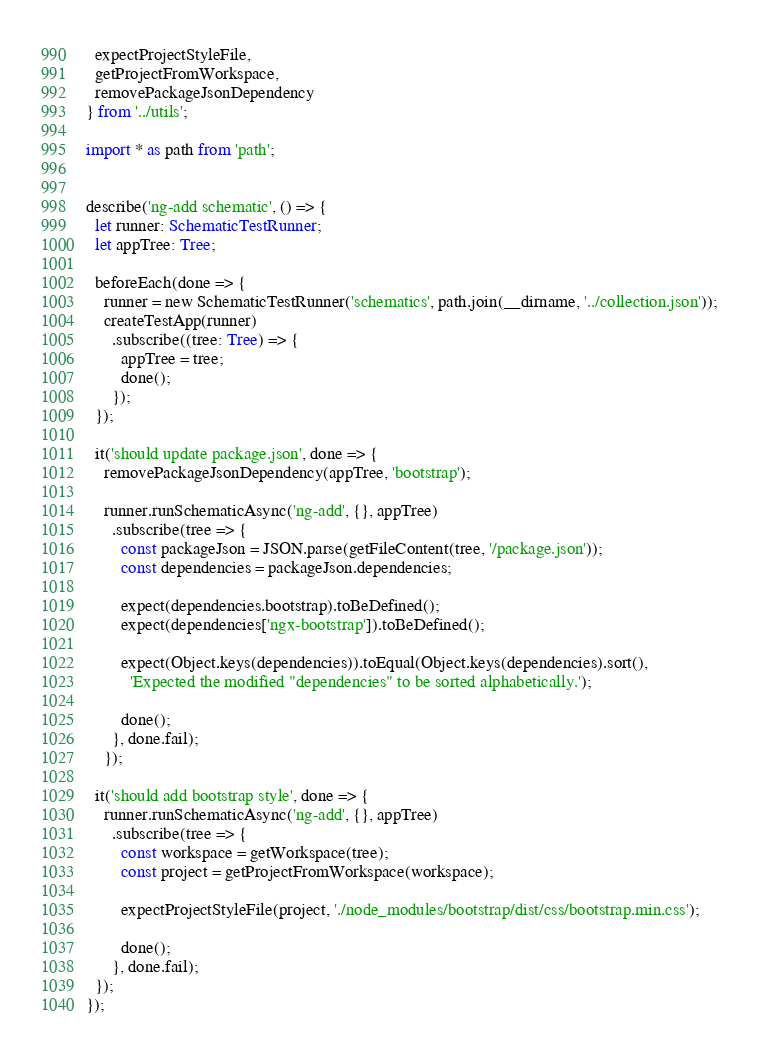<code> <loc_0><loc_0><loc_500><loc_500><_TypeScript_>  expectProjectStyleFile,
  getProjectFromWorkspace,
  removePackageJsonDependency
} from '../utils';

import * as path from 'path';


describe('ng-add schematic', () => {
  let runner: SchematicTestRunner;
  let appTree: Tree;

  beforeEach(done => {
    runner = new SchematicTestRunner('schematics', path.join(__dirname, '../collection.json'));
    createTestApp(runner)
      .subscribe((tree: Tree) => {
        appTree = tree;
        done();
      });
  });

  it('should update package.json', done => {
    removePackageJsonDependency(appTree, 'bootstrap');

    runner.runSchematicAsync('ng-add', {}, appTree)
      .subscribe(tree => {
        const packageJson = JSON.parse(getFileContent(tree, '/package.json'));
        const dependencies = packageJson.dependencies;

        expect(dependencies.bootstrap).toBeDefined();
        expect(dependencies['ngx-bootstrap']).toBeDefined();

        expect(Object.keys(dependencies)).toEqual(Object.keys(dependencies).sort(),
          'Expected the modified "dependencies" to be sorted alphabetically.');

        done();
      }, done.fail);
    });

  it('should add bootstrap style', done => {
    runner.runSchematicAsync('ng-add', {}, appTree)
      .subscribe(tree => {
        const workspace = getWorkspace(tree);
        const project = getProjectFromWorkspace(workspace);

        expectProjectStyleFile(project, './node_modules/bootstrap/dist/css/bootstrap.min.css');

        done();
      }, done.fail);
  });
});
</code> 